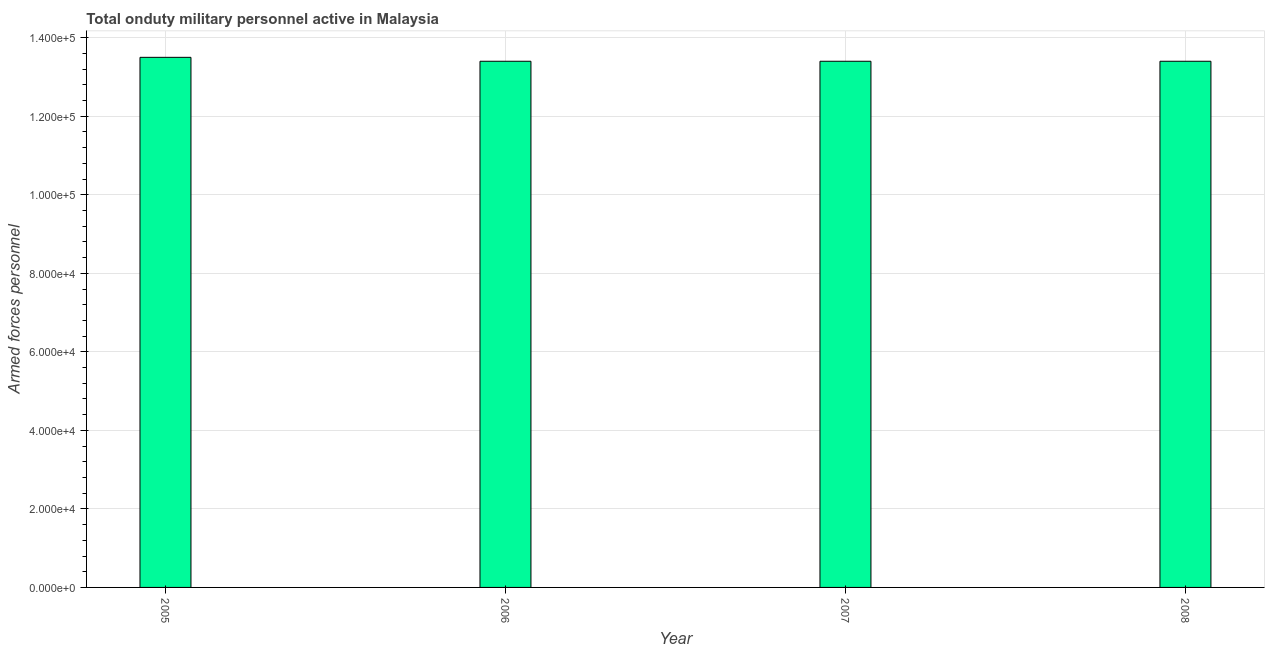What is the title of the graph?
Keep it short and to the point. Total onduty military personnel active in Malaysia. What is the label or title of the X-axis?
Your answer should be very brief. Year. What is the label or title of the Y-axis?
Your answer should be compact. Armed forces personnel. What is the number of armed forces personnel in 2008?
Your answer should be compact. 1.34e+05. Across all years, what is the maximum number of armed forces personnel?
Provide a short and direct response. 1.35e+05. Across all years, what is the minimum number of armed forces personnel?
Keep it short and to the point. 1.34e+05. In which year was the number of armed forces personnel minimum?
Give a very brief answer. 2006. What is the sum of the number of armed forces personnel?
Make the answer very short. 5.37e+05. What is the average number of armed forces personnel per year?
Offer a very short reply. 1.34e+05. What is the median number of armed forces personnel?
Keep it short and to the point. 1.34e+05. Do a majority of the years between 2008 and 2006 (inclusive) have number of armed forces personnel greater than 68000 ?
Provide a succinct answer. Yes. What is the ratio of the number of armed forces personnel in 2005 to that in 2008?
Your response must be concise. 1.01. Is the number of armed forces personnel in 2005 less than that in 2008?
Ensure brevity in your answer.  No. Is the difference between the number of armed forces personnel in 2006 and 2008 greater than the difference between any two years?
Your response must be concise. No. What is the difference between the highest and the second highest number of armed forces personnel?
Offer a very short reply. 1000. Is the sum of the number of armed forces personnel in 2005 and 2006 greater than the maximum number of armed forces personnel across all years?
Make the answer very short. Yes. In how many years, is the number of armed forces personnel greater than the average number of armed forces personnel taken over all years?
Provide a short and direct response. 1. How many bars are there?
Make the answer very short. 4. How many years are there in the graph?
Your answer should be compact. 4. What is the Armed forces personnel in 2005?
Give a very brief answer. 1.35e+05. What is the Armed forces personnel of 2006?
Ensure brevity in your answer.  1.34e+05. What is the Armed forces personnel of 2007?
Your answer should be very brief. 1.34e+05. What is the Armed forces personnel in 2008?
Your response must be concise. 1.34e+05. What is the difference between the Armed forces personnel in 2005 and 2007?
Make the answer very short. 1000. What is the ratio of the Armed forces personnel in 2005 to that in 2007?
Ensure brevity in your answer.  1.01. What is the ratio of the Armed forces personnel in 2005 to that in 2008?
Make the answer very short. 1.01. What is the ratio of the Armed forces personnel in 2006 to that in 2007?
Make the answer very short. 1. 